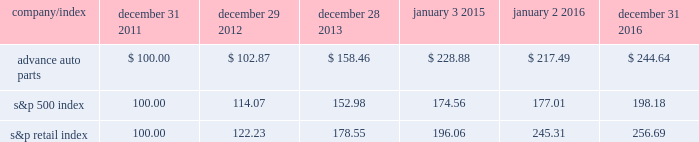Stock price performance the following graph shows a comparison of the cumulative total return on our common stock , the standard & poor 2019s 500 index and the standard & poor 2019s retail index .
The graph assumes that the value of an investment in our common stock and in each such index was $ 100 on december 31 , 2011 , and that any dividends have been reinvested .
The comparison in the graph below is based solely on historical data and is not intended to forecast the possible future performance of our common stock .
Comparison of cumulative total return among advance auto parts , inc. , s&p 500 index and s&p retail index company/index december 31 , december 29 , december 28 , january 3 , january 2 , december 31 .

What is the rate of return on an investment in advance auto parts from 2015 to 2016? 
Computations: ((217.49 - 228.88) / 228.88)
Answer: -0.04976. 